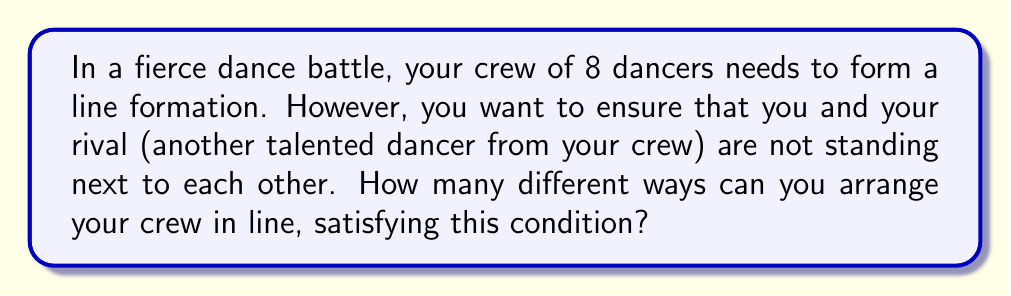Help me with this question. Let's approach this step-by-step:

1) First, let's consider the total number of ways to arrange 8 dancers without any restrictions:
   $8! = 40,320$

2) Now, we need to subtract the arrangements where you and your rival are adjacent.

3) To count these adjacent arrangements:
   a) Consider you and your rival as a single unit. Now we have 7 units to arrange (the pair and 6 other dancers).
   b) These 7 units can be arranged in $7! = 5,040$ ways.
   c) For each of these arrangements, you and your rival can swap positions. So we multiply by 2.

4) Therefore, the number of arrangements with you and your rival adjacent is:
   $7! \times 2 = 5,040 \times 2 = 10,080$

5) The final answer is the total arrangements minus the adjacent arrangements:
   $8! - (7! \times 2) = 40,320 - 10,080 = 30,240$

Thus, there are 30,240 ways to arrange your crew with you and your rival not adjacent.
Answer: 30,240 